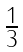Convert formula to latex. <formula><loc_0><loc_0><loc_500><loc_500>\begin{array} { l } { { \frac { 1 } { 3 } } } \end{array}</formula> 